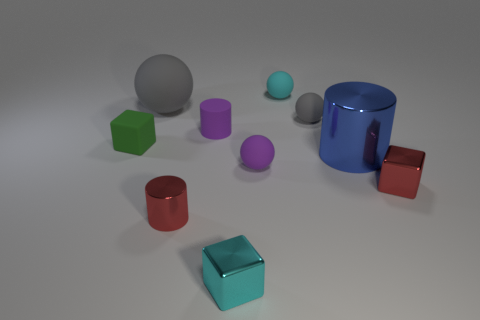There is a tiny metallic object that is the same color as the tiny shiny cylinder; what shape is it?
Your answer should be very brief. Cube. How many big shiny things have the same shape as the small green matte object?
Your response must be concise. 0. What shape is the tiny gray object that is the same material as the small green cube?
Offer a very short reply. Sphere. There is a gray ball to the left of the tiny cyan rubber thing on the left side of the gray ball in front of the big rubber ball; what is it made of?
Your answer should be compact. Rubber. There is a purple matte cylinder; is it the same size as the metal cylinder that is behind the purple rubber ball?
Keep it short and to the point. No. There is a small purple object that is the same shape as the big metallic thing; what material is it?
Keep it short and to the point. Rubber. There is a red metal thing left of the tiny cyan object behind the thing to the right of the blue cylinder; what size is it?
Make the answer very short. Small. Does the matte block have the same size as the purple rubber cylinder?
Your answer should be very brief. Yes. What is the material of the red thing that is on the left side of the red thing that is right of the purple sphere?
Provide a short and direct response. Metal. There is a red object that is on the left side of the small cyan metal cube; does it have the same shape as the cyan object that is behind the red metal block?
Provide a short and direct response. No. 